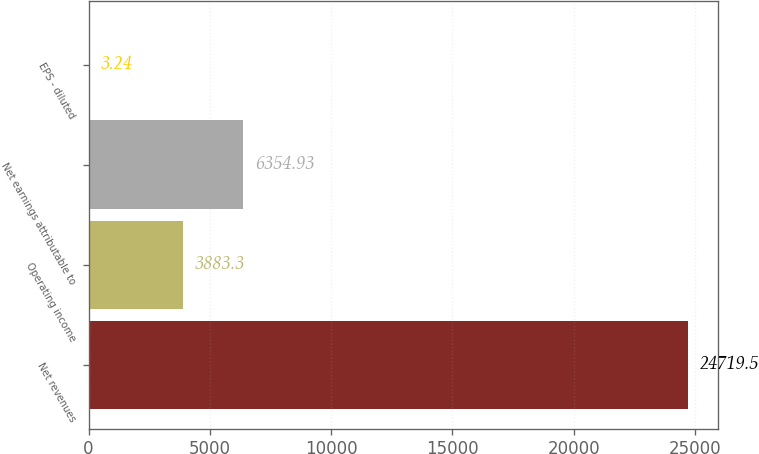Convert chart to OTSL. <chart><loc_0><loc_0><loc_500><loc_500><bar_chart><fcel>Net revenues<fcel>Operating income<fcel>Net earnings attributable to<fcel>EPS - diluted<nl><fcel>24719.5<fcel>3883.3<fcel>6354.93<fcel>3.24<nl></chart> 